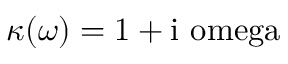<formula> <loc_0><loc_0><loc_500><loc_500>\kappa ( \omega ) = 1 + i \ o m e g a</formula> 